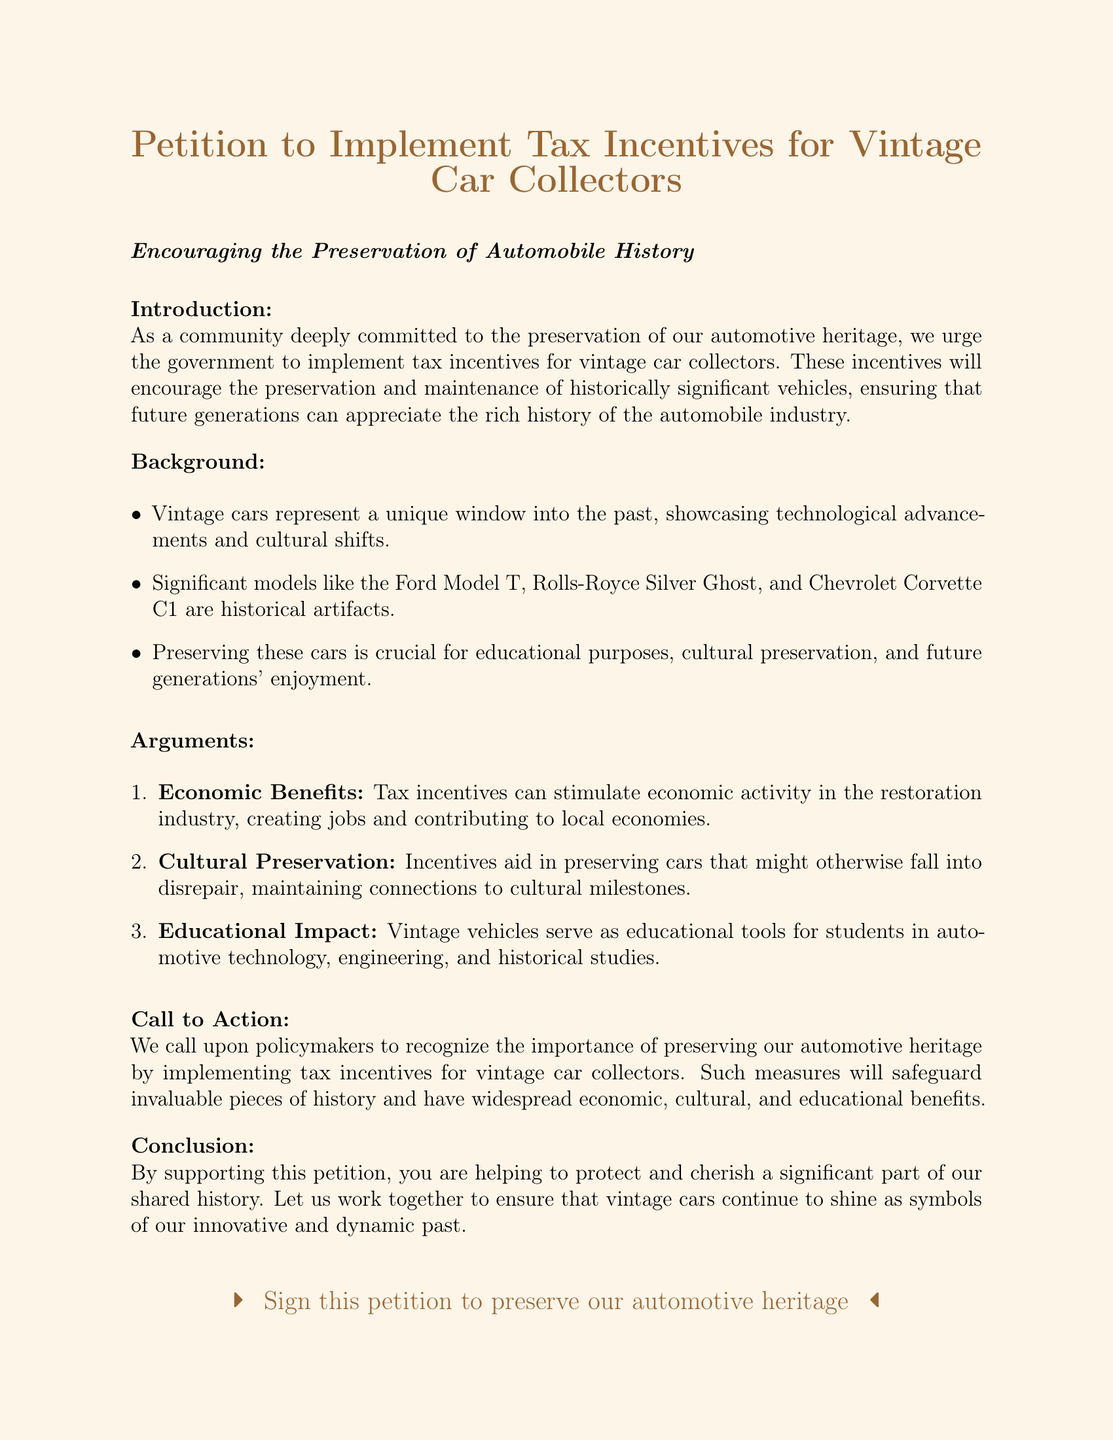What is the title of the petition? The title is stated at the top of the document, which highlights the focus of the petition.
Answer: Petition to Implement Tax Incentives for Vintage Car Collectors What are vintage cars described as? The document mentions that vintage cars represent a unique window into the past.
Answer: Unique window into the past Which models are highlighted as historical artifacts? The document lists significant models that are considered historical artifacts.
Answer: Ford Model T, Rolls-Royce Silver Ghost, Chevrolet Corvette C1 What is one argument made for tax incentives? The document presents various arguments in favor of the incentives, highlighting their potential benefits.
Answer: Economic Benefits What does the call to action ask policymakers to recognize? The call to action emphasizes the importance of preserving automotive heritage through specific measures.
Answer: Importance of preserving our automotive heritage What is the educational impact mentioned in the arguments? The document discusses how vintage vehicles serve as educational tools in various fields.
Answer: Educational tools for students Who presented the petition? The document indicates who is behind the petition and their professional background.
Answer: A renowned car journalist What color is the page background? The document specifies the color theme used in the background of the page.
Answer: Light brown 